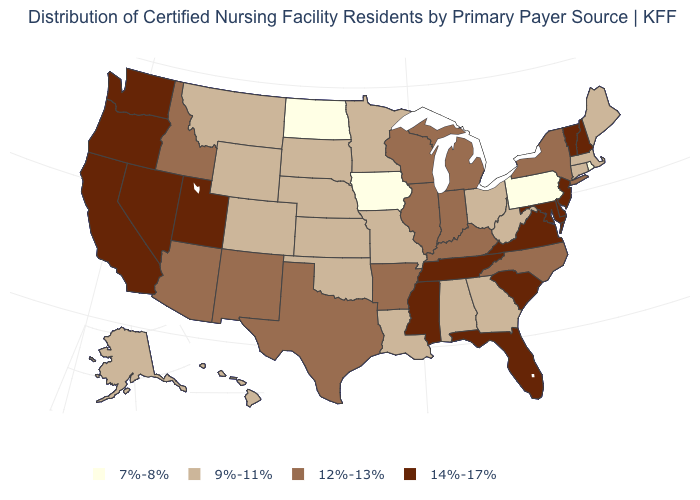Does California have the highest value in the West?
Concise answer only. Yes. What is the value of West Virginia?
Write a very short answer. 9%-11%. Name the states that have a value in the range 7%-8%?
Write a very short answer. Iowa, North Dakota, Pennsylvania, Rhode Island. What is the lowest value in the West?
Keep it brief. 9%-11%. Name the states that have a value in the range 7%-8%?
Answer briefly. Iowa, North Dakota, Pennsylvania, Rhode Island. What is the lowest value in the USA?
Short answer required. 7%-8%. What is the value of New Jersey?
Short answer required. 14%-17%. Name the states that have a value in the range 7%-8%?
Keep it brief. Iowa, North Dakota, Pennsylvania, Rhode Island. What is the value of Illinois?
Quick response, please. 12%-13%. Name the states that have a value in the range 12%-13%?
Concise answer only. Arizona, Arkansas, Idaho, Illinois, Indiana, Kentucky, Michigan, New Mexico, New York, North Carolina, Texas, Wisconsin. What is the value of Hawaii?
Write a very short answer. 9%-11%. What is the value of Utah?
Write a very short answer. 14%-17%. What is the value of South Dakota?
Short answer required. 9%-11%. 